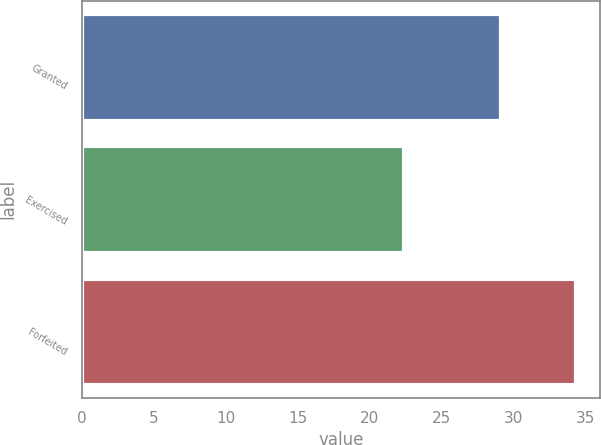Convert chart to OTSL. <chart><loc_0><loc_0><loc_500><loc_500><bar_chart><fcel>Granted<fcel>Exercised<fcel>Forfeited<nl><fcel>29.09<fcel>22.35<fcel>34.3<nl></chart> 